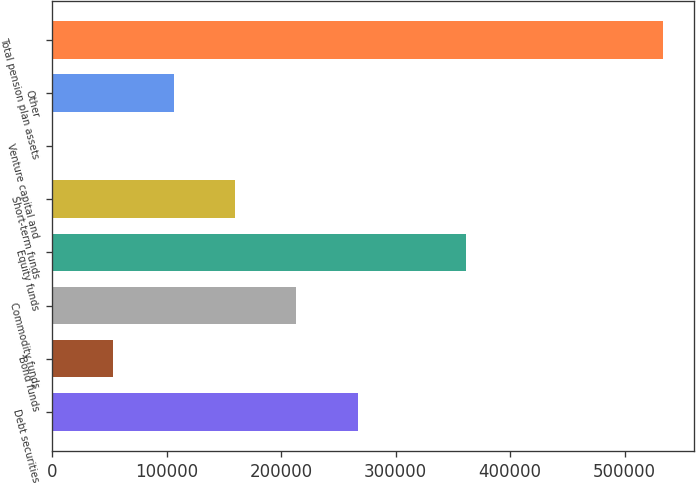<chart> <loc_0><loc_0><loc_500><loc_500><bar_chart><fcel>Debt securities<fcel>Bond funds<fcel>Commodity funds<fcel>Equity funds<fcel>Short-term funds<fcel>Venture capital and<fcel>Other<fcel>Total pension plan assets<nl><fcel>266812<fcel>53364.4<fcel>213450<fcel>361190<fcel>160088<fcel>2.57<fcel>106726<fcel>533621<nl></chart> 